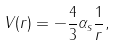<formula> <loc_0><loc_0><loc_500><loc_500>V ( r ) = - \frac { 4 } { 3 } \alpha _ { s } \frac { 1 } { r } ,</formula> 